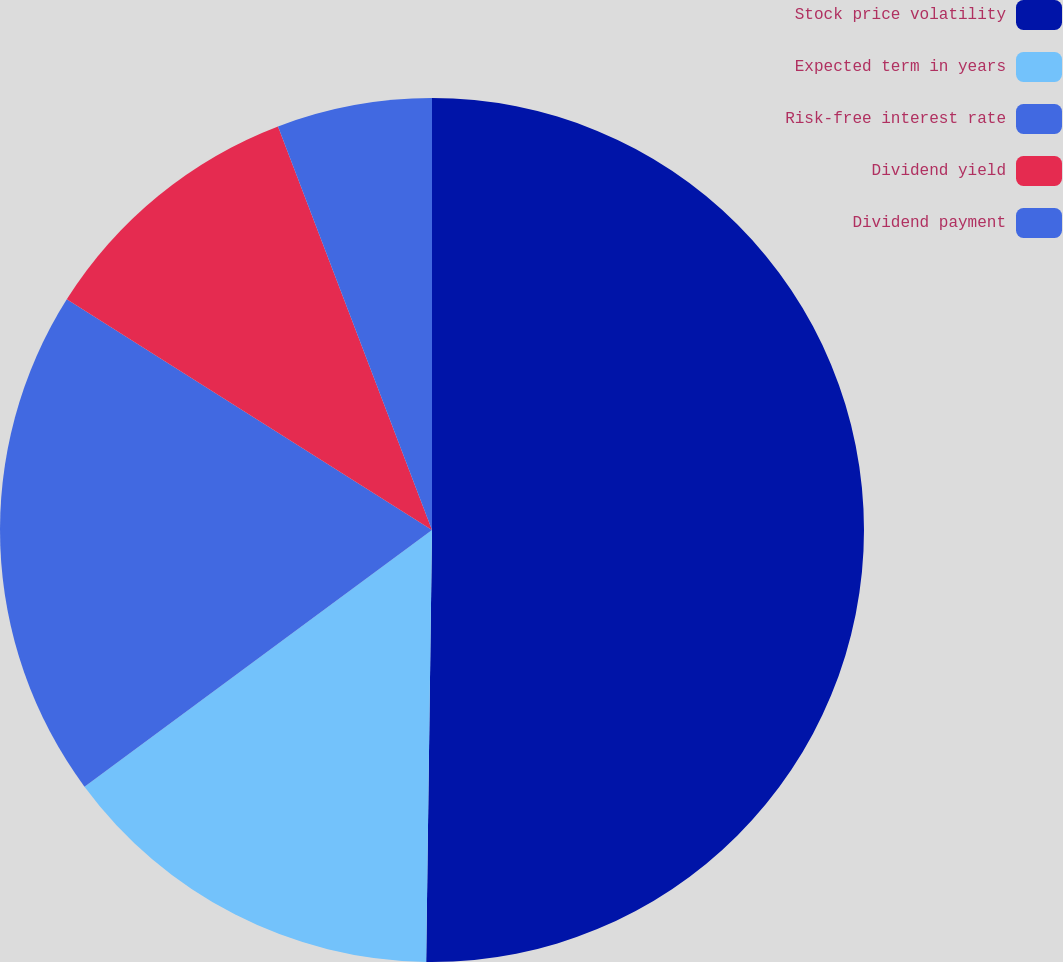<chart> <loc_0><loc_0><loc_500><loc_500><pie_chart><fcel>Stock price volatility<fcel>Expected term in years<fcel>Risk-free interest rate<fcel>Dividend yield<fcel>Dividend payment<nl><fcel>50.21%<fcel>14.66%<fcel>19.09%<fcel>10.23%<fcel>5.8%<nl></chart> 